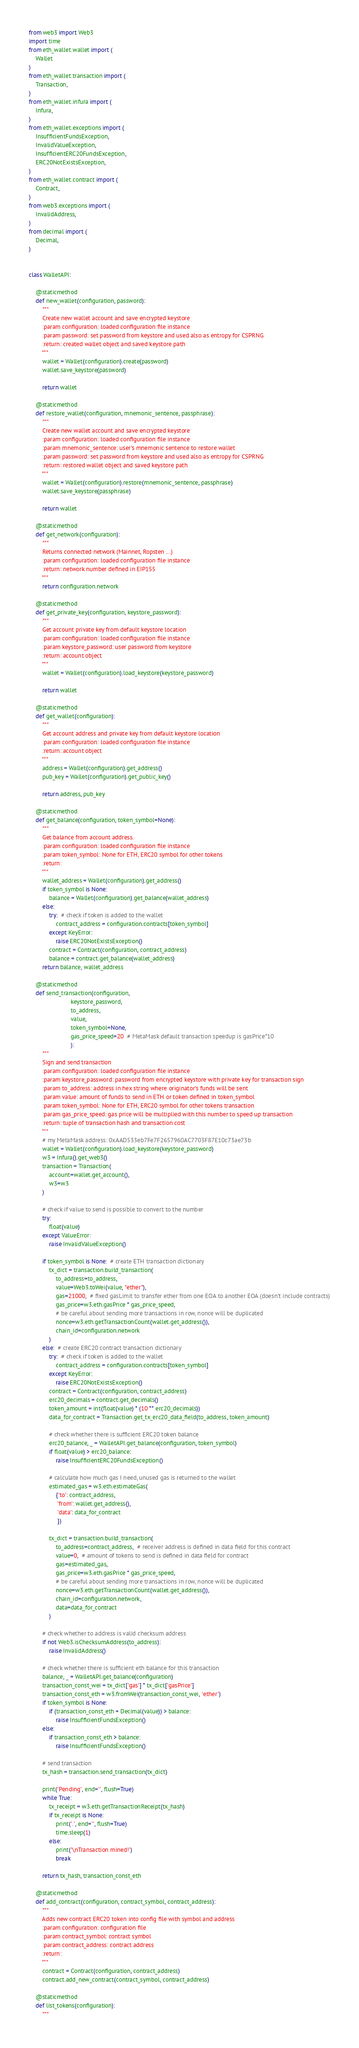Convert code to text. <code><loc_0><loc_0><loc_500><loc_500><_Python_>from web3 import Web3
import time
from eth_wallet.wallet import (
    Wallet
)
from eth_wallet.transaction import (
    Transaction,
)
from eth_wallet.infura import (
    Infura,
)
from eth_wallet.exceptions import (
    InsufficientFundsException,
    InvalidValueException,
    InsufficientERC20FundsException,
    ERC20NotExistsException,
)
from eth_wallet.contract import (
    Contract,
)
from web3.exceptions import (
    InvalidAddress,
)
from decimal import (
    Decimal,
)


class WalletAPI:

    @staticmethod
    def new_wallet(configuration, password):
        """
        Create new wallet account and save encrypted keystore
        :param configuration: loaded configuration file instance
        :param password: set password from keystore and used also as entropy for CSPRNG
        :return: created wallet object and saved keystore path
        """
        wallet = Wallet(configuration).create(password)
        wallet.save_keystore(password)

        return wallet

    @staticmethod
    def restore_wallet(configuration, mnemonic_sentence, passphrase):
        """
        Create new wallet account and save encrypted keystore
        :param configuration: loaded configuration file instance
        :param mnemonic_sentence: user's mnemonic sentence to restore wallet
        :param password: set password from keystore and used also as entropy for CSPRNG
        :return: restored wallet object and saved keystore path
        """
        wallet = Wallet(configuration).restore(mnemonic_sentence, passphrase)
        wallet.save_keystore(passphrase)

        return wallet

    @staticmethod
    def get_network(configuration):
        """
        Returns connected network (Mainnet, Ropsten ...)
        :param configuration: loaded configuration file instance
        :return: network number defined in EIP155
        """
        return configuration.network

    @staticmethod
    def get_private_key(configuration, keystore_password):
        """
        Get account private key from default keystore location
        :param configuration: loaded configuration file instance
        :param keystore_password: user password from keystore
        :return: account object
        """
        wallet = Wallet(configuration).load_keystore(keystore_password)

        return wallet

    @staticmethod
    def get_wallet(configuration):
        """
        Get account address and private key from default keystore location
        :param configuration: loaded configuration file instance
        :return: account object
        """
        address = Wallet(configuration).get_address()
        pub_key = Wallet(configuration).get_public_key()

        return address, pub_key

    @staticmethod
    def get_balance(configuration, token_symbol=None):
        """
        Get balance from account address.
        :param configuration: loaded configuration file instance
        :param token_symbol: None for ETH, ERC20 symbol for other tokens
        :return:
        """
        wallet_address = Wallet(configuration).get_address()
        if token_symbol is None:
            balance = Wallet(configuration).get_balance(wallet_address)
        else:
            try:  # check if token is added to the wallet
                contract_address = configuration.contracts[token_symbol]
            except KeyError:
                raise ERC20NotExistsException()
            contract = Contract(configuration, contract_address)
            balance = contract.get_balance(wallet_address)
        return balance, wallet_address

    @staticmethod
    def send_transaction(configuration,
                         keystore_password,
                         to_address,
                         value,
                         token_symbol=None,
                         gas_price_speed=20  # MetaMask default transaction speedup is gasPrice*10
                         ):
        """
        Sign and send transaction
        :param configuration: loaded configuration file instance
        :param keystore_password: password from encrypted keystore with private key for transaction sign
        :param to_address: address in hex string where originator's funds will be sent
        :param value: amount of funds to send in ETH or token defined in token_symbol
        :param token_symbol: None for ETH, ERC20 symbol for other tokens transaction
        :param gas_price_speed: gas price will be multiplied with this number to speed up transaction
        :return: tuple of transaction hash and transaction cost
        """
        # my MetaMask address: 0xAAD533eb7Fe7F2657960AC7703F87E10c73ae73b
        wallet = Wallet(configuration).load_keystore(keystore_password)
        w3 = Infura().get_web3()
        transaction = Transaction(
            account=wallet.get_account(),
            w3=w3
        )

        # check if value to send is possible to convert to the number
        try:
            float(value)
        except ValueError:
            raise InvalidValueException()

        if token_symbol is None:  # create ETH transaction dictionary
            tx_dict = transaction.build_transaction(
                to_address=to_address,
                value=Web3.toWei(value, "ether"),
                gas=21000,  # fixed gasLimit to transfer ether from one EOA to another EOA (doesn't include contracts)
                gas_price=w3.eth.gasPrice * gas_price_speed,
                # be careful about sending more transactions in row, nonce will be duplicated
                nonce=w3.eth.getTransactionCount(wallet.get_address()),
                chain_id=configuration.network
            )
        else:  # create ERC20 contract transaction dictionary
            try:  # check if token is added to the wallet
                contract_address = configuration.contracts[token_symbol]
            except KeyError:
                raise ERC20NotExistsException()
            contract = Contract(configuration, contract_address)
            erc20_decimals = contract.get_decimals()
            token_amount = int(float(value) * (10 ** erc20_decimals))
            data_for_contract = Transaction.get_tx_erc20_data_field(to_address, token_amount)

            # check whether there is sufficient ERC20 token balance
            erc20_balance, _ = WalletAPI.get_balance(configuration, token_symbol)
            if float(value) > erc20_balance:
                raise InsufficientERC20FundsException()

            # calculate how much gas I need, unused gas is returned to the wallet
            estimated_gas = w3.eth.estimateGas(
                {'to': contract_address,
                 'from': wallet.get_address(),
                 'data': data_for_contract
                 })

            tx_dict = transaction.build_transaction(
                to_address=contract_address,  # receiver address is defined in data field for this contract
                value=0,  # amount of tokens to send is defined in data field for contract
                gas=estimated_gas,
                gas_price=w3.eth.gasPrice * gas_price_speed,
                # be careful about sending more transactions in row, nonce will be duplicated
                nonce=w3.eth.getTransactionCount(wallet.get_address()),
                chain_id=configuration.network,
                data=data_for_contract
            )

        # check whether to address is valid checksum address
        if not Web3.isChecksumAddress(to_address):
            raise InvalidAddress()

        # check whether there is sufficient eth balance for this transaction
        balance, _ = WalletAPI.get_balance(configuration)
        transaction_const_wei = tx_dict['gas'] * tx_dict['gasPrice']
        transaction_const_eth = w3.fromWei(transaction_const_wei, 'ether')
        if token_symbol is None:
            if (transaction_const_eth + Decimal(value)) > balance:
                raise InsufficientFundsException()
        else:
            if transaction_const_eth > balance:
                raise InsufficientFundsException()

        # send transaction
        tx_hash = transaction.send_transaction(tx_dict)

        print('Pending', end='', flush=True)
        while True:
            tx_receipt = w3.eth.getTransactionReceipt(tx_hash)
            if tx_receipt is None:
                print('.', end='', flush=True)
                time.sleep(1)
            else:
                print('\nTransaction mined!')
                break

        return tx_hash, transaction_const_eth

    @staticmethod
    def add_contract(configuration, contract_symbol, contract_address):
        """
        Adds new contract ERC20 token into config file with symbol and address
        :param configuration: configuration file
        :param contract_symbol: contract symbol
        :param contract_address: contract address
        :return:
        """
        contract = Contract(configuration, contract_address)
        contract.add_new_contract(contract_symbol, contract_address)

    @staticmethod
    def list_tokens(configuration):
        """</code> 